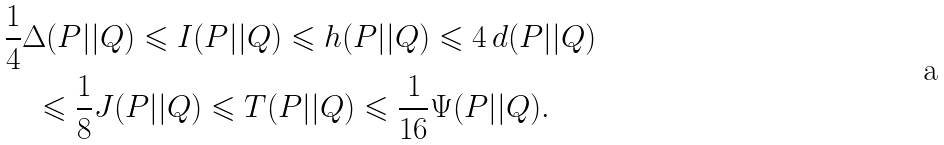<formula> <loc_0><loc_0><loc_500><loc_500>& \frac { 1 } { 4 } \Delta ( P | | Q ) \leqslant I ( P | | Q ) \leqslant h ( P | | Q ) \leqslant 4 \, d ( P | | Q ) \\ & \quad \leqslant \frac { 1 } { 8 } J ( P | | Q ) \leqslant T ( P | | Q ) \leqslant \frac { 1 } { 1 6 } \Psi ( P | | Q ) .</formula> 